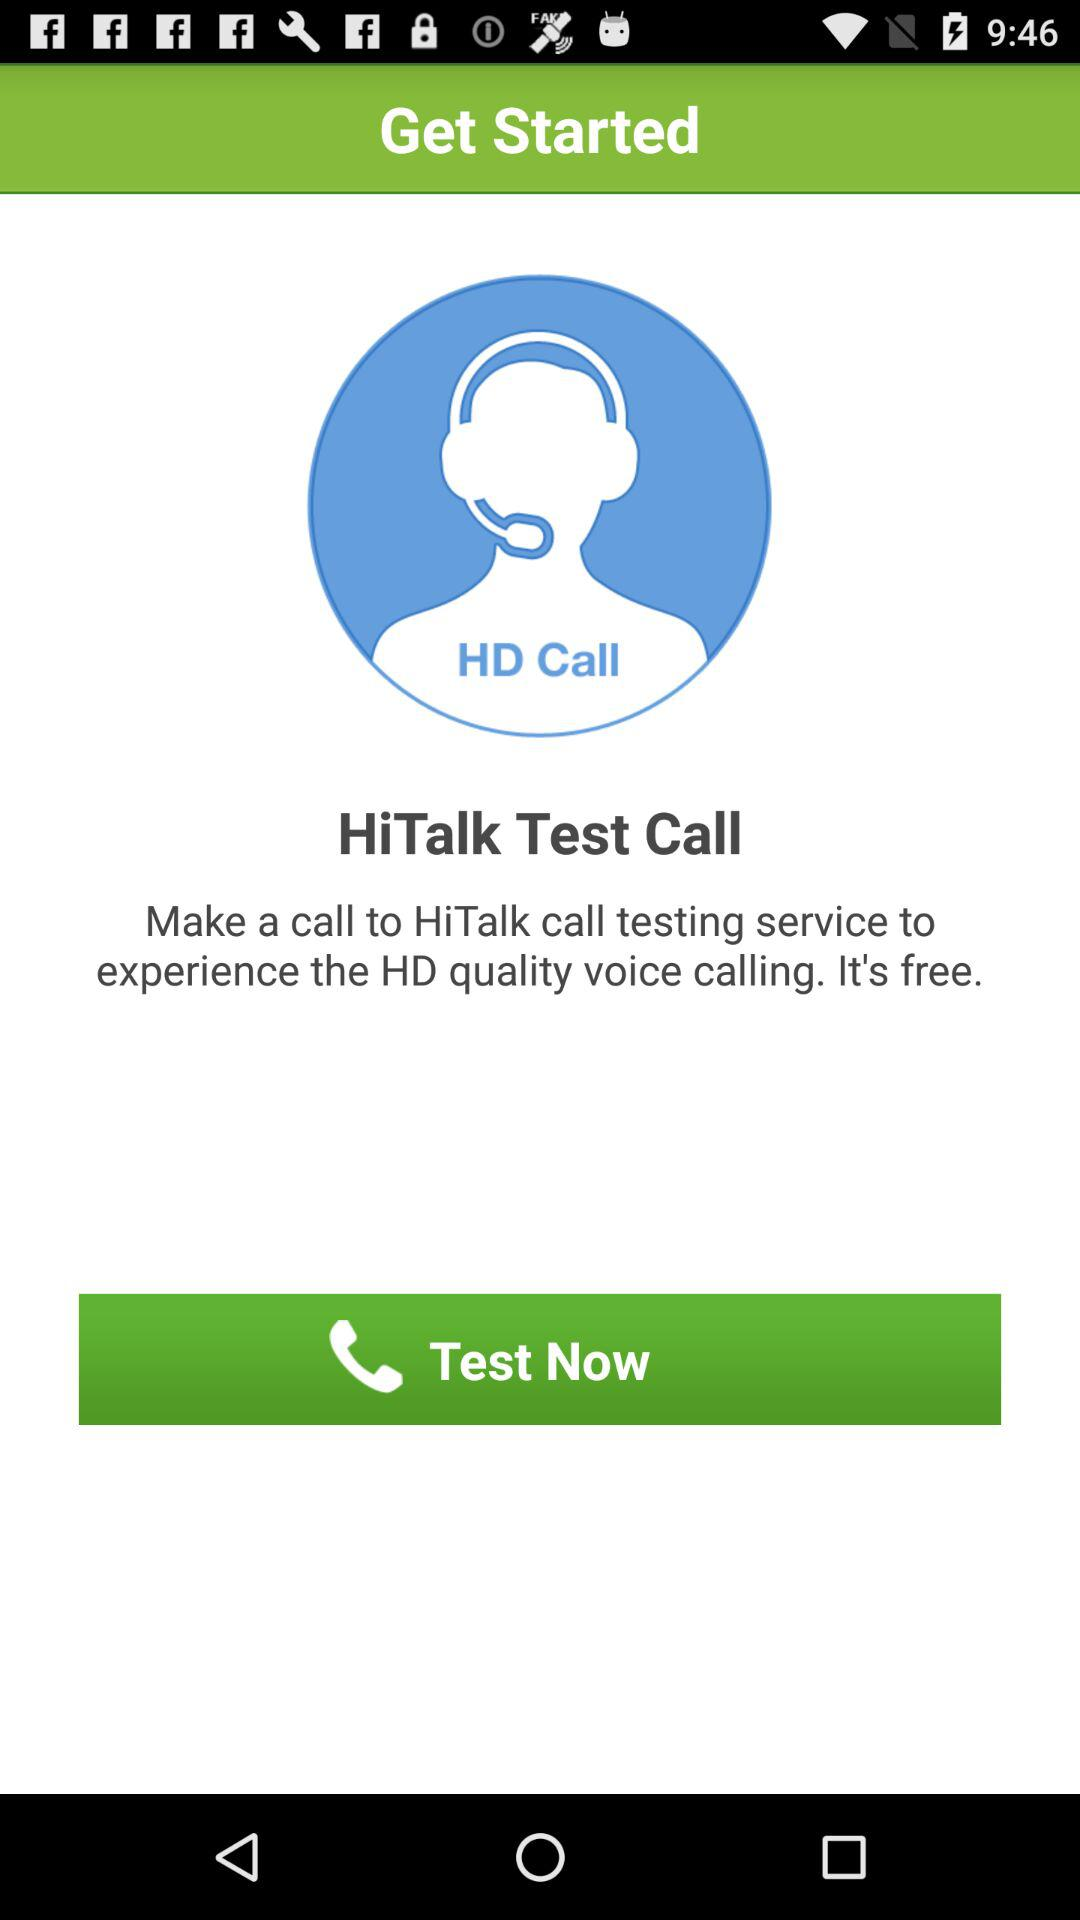Is the app free or paid? The app is free. 